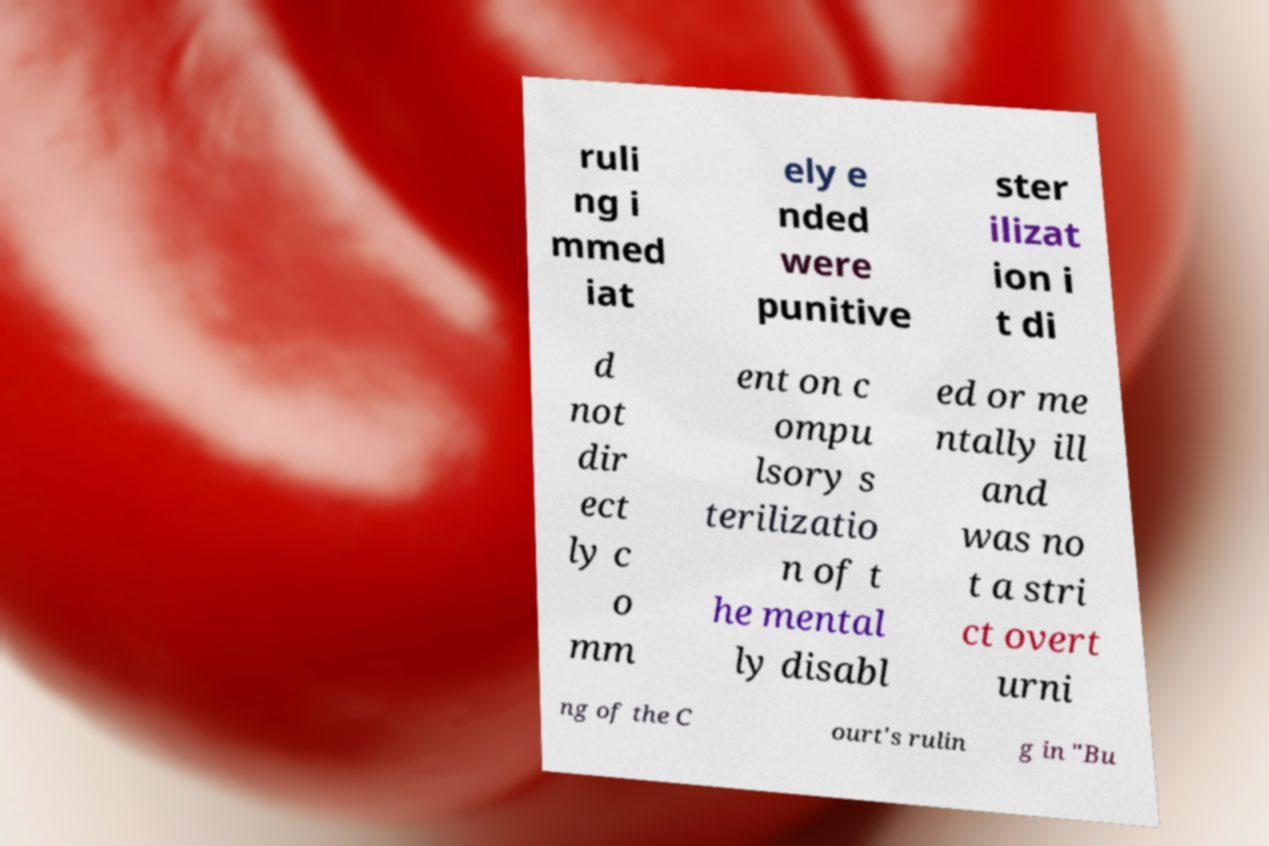Please read and relay the text visible in this image. What does it say? ruli ng i mmed iat ely e nded were punitive ster ilizat ion i t di d not dir ect ly c o mm ent on c ompu lsory s terilizatio n of t he mental ly disabl ed or me ntally ill and was no t a stri ct overt urni ng of the C ourt's rulin g in "Bu 